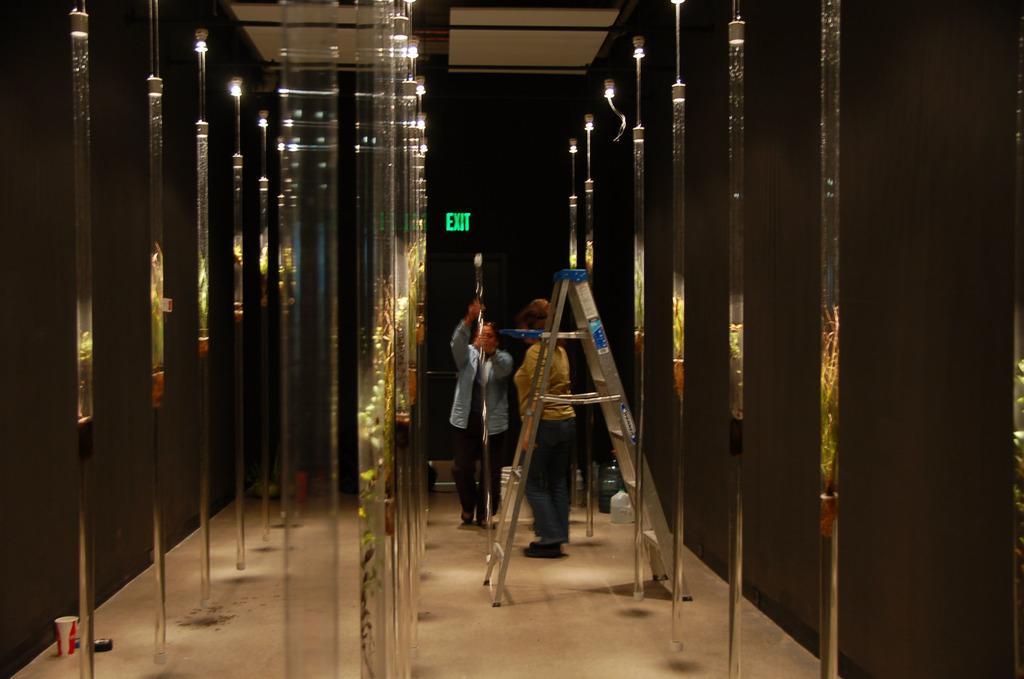What does the green neon sign indicate?
Provide a succinct answer. Exit. How many letters are in the lite up sign?
Your response must be concise. 4. 